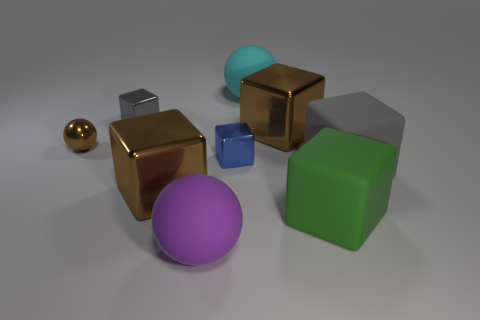Subtract all red cylinders. How many brown blocks are left? 2 Subtract all large spheres. How many spheres are left? 1 Add 1 red shiny objects. How many objects exist? 10 Subtract all cyan balls. How many balls are left? 2 Subtract 1 balls. How many balls are left? 2 Subtract all blocks. How many objects are left? 3 Subtract all red cubes. Subtract all blue cylinders. How many cubes are left? 6 Add 4 gray rubber cylinders. How many gray rubber cylinders exist? 4 Subtract 0 red blocks. How many objects are left? 9 Subtract all large shiny balls. Subtract all cyan balls. How many objects are left? 8 